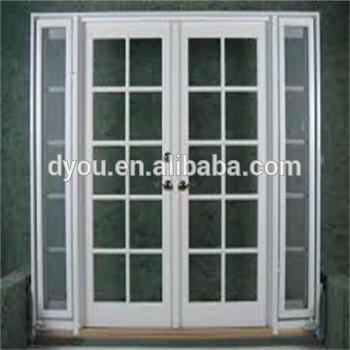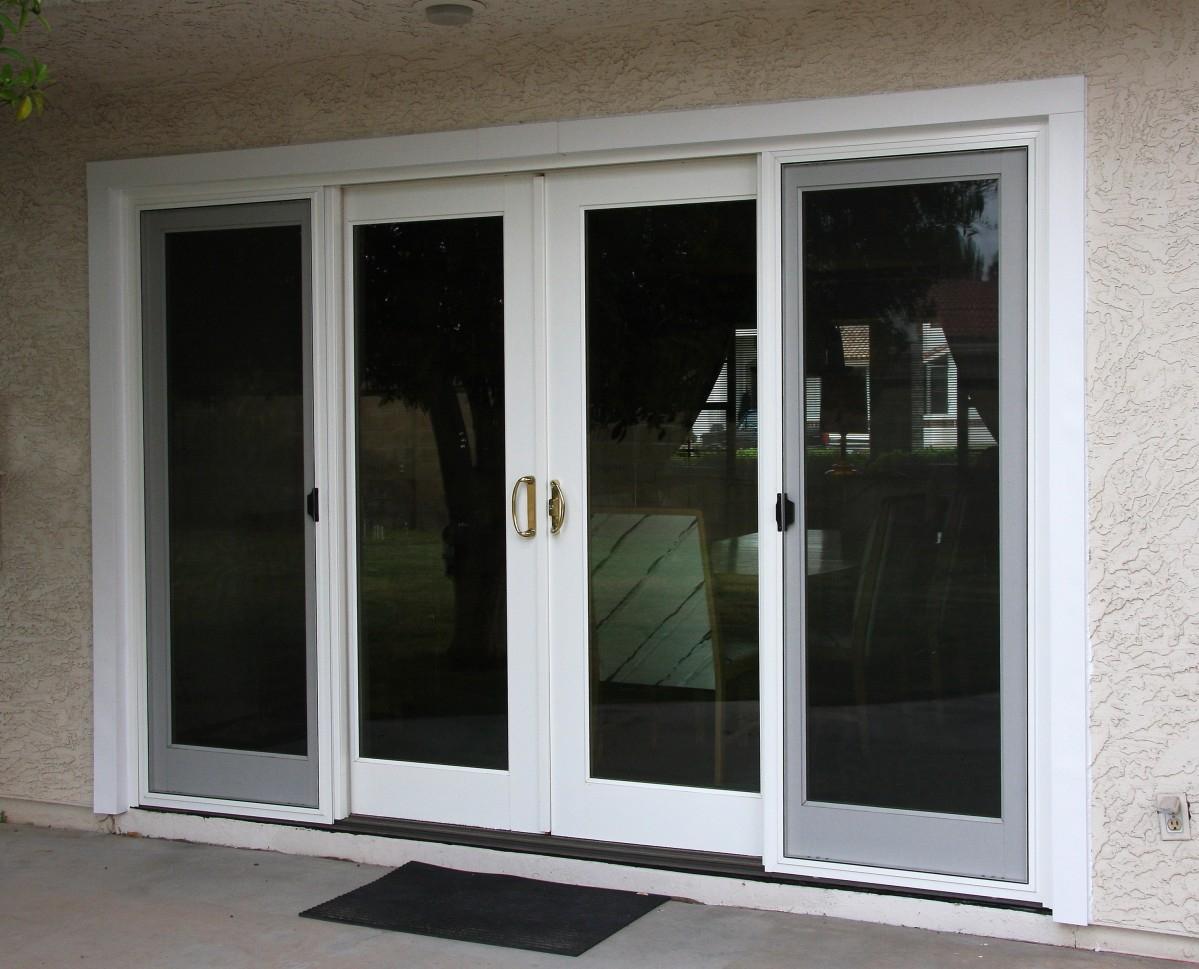The first image is the image on the left, the second image is the image on the right. For the images shown, is this caption "A floor mat sits outside one of the doors." true? Answer yes or no. Yes. The first image is the image on the left, the second image is the image on the right. Evaluate the accuracy of this statement regarding the images: "Right image shows a sliding door unit with four door-shaped sections that don't have paned glass.". Is it true? Answer yes or no. Yes. 